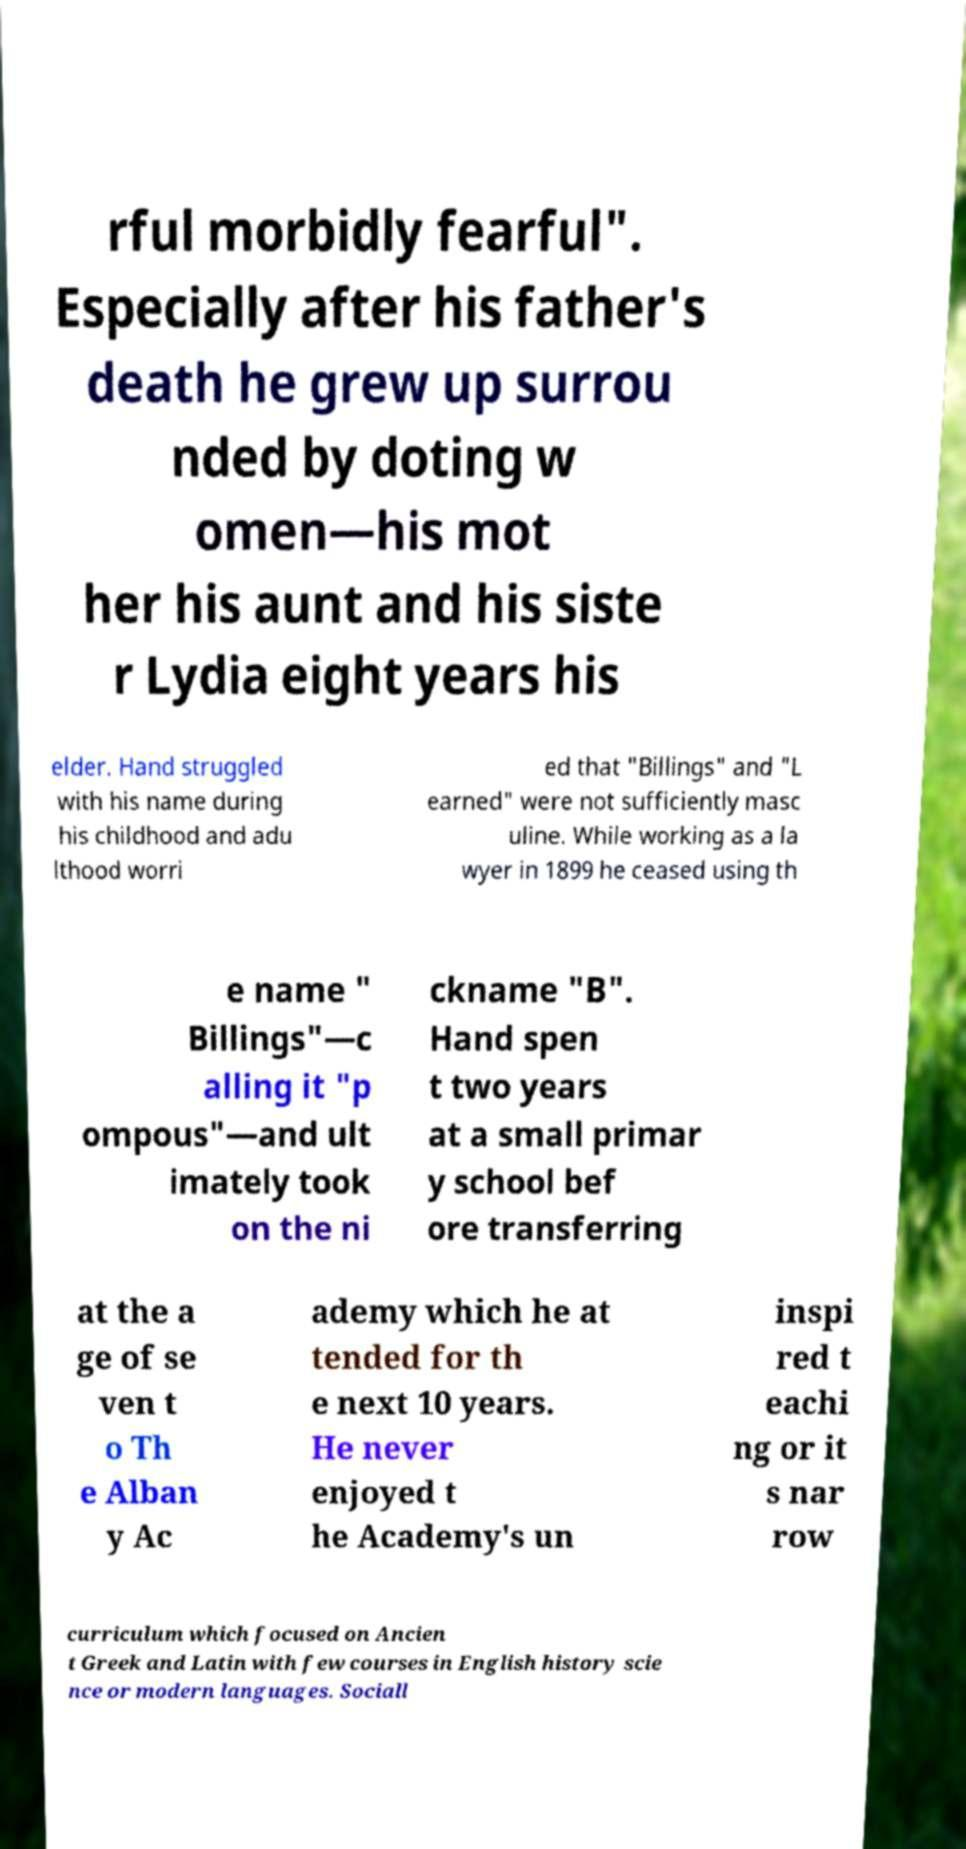There's text embedded in this image that I need extracted. Can you transcribe it verbatim? rful morbidly fearful". Especially after his father's death he grew up surrou nded by doting w omen—his mot her his aunt and his siste r Lydia eight years his elder. Hand struggled with his name during his childhood and adu lthood worri ed that "Billings" and "L earned" were not sufficiently masc uline. While working as a la wyer in 1899 he ceased using th e name " Billings"—c alling it "p ompous"—and ult imately took on the ni ckname "B". Hand spen t two years at a small primar y school bef ore transferring at the a ge of se ven t o Th e Alban y Ac ademy which he at tended for th e next 10 years. He never enjoyed t he Academy's un inspi red t eachi ng or it s nar row curriculum which focused on Ancien t Greek and Latin with few courses in English history scie nce or modern languages. Sociall 